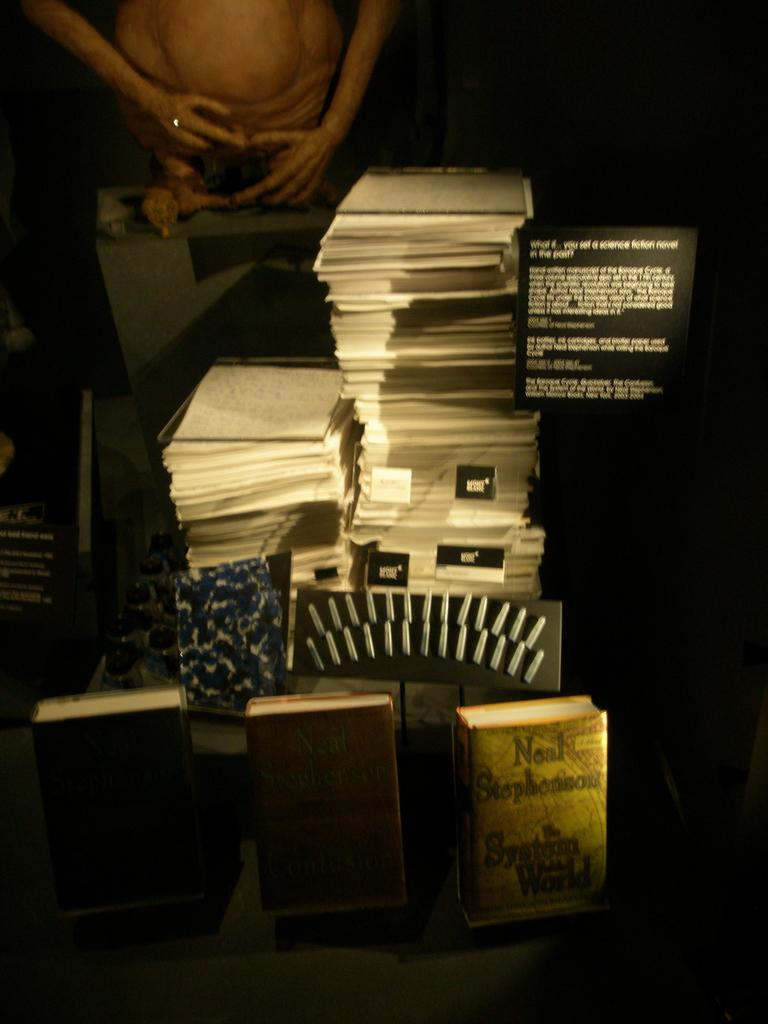<image>
Summarize the visual content of the image. A stack of paper and books on display by Neal Stephenson 